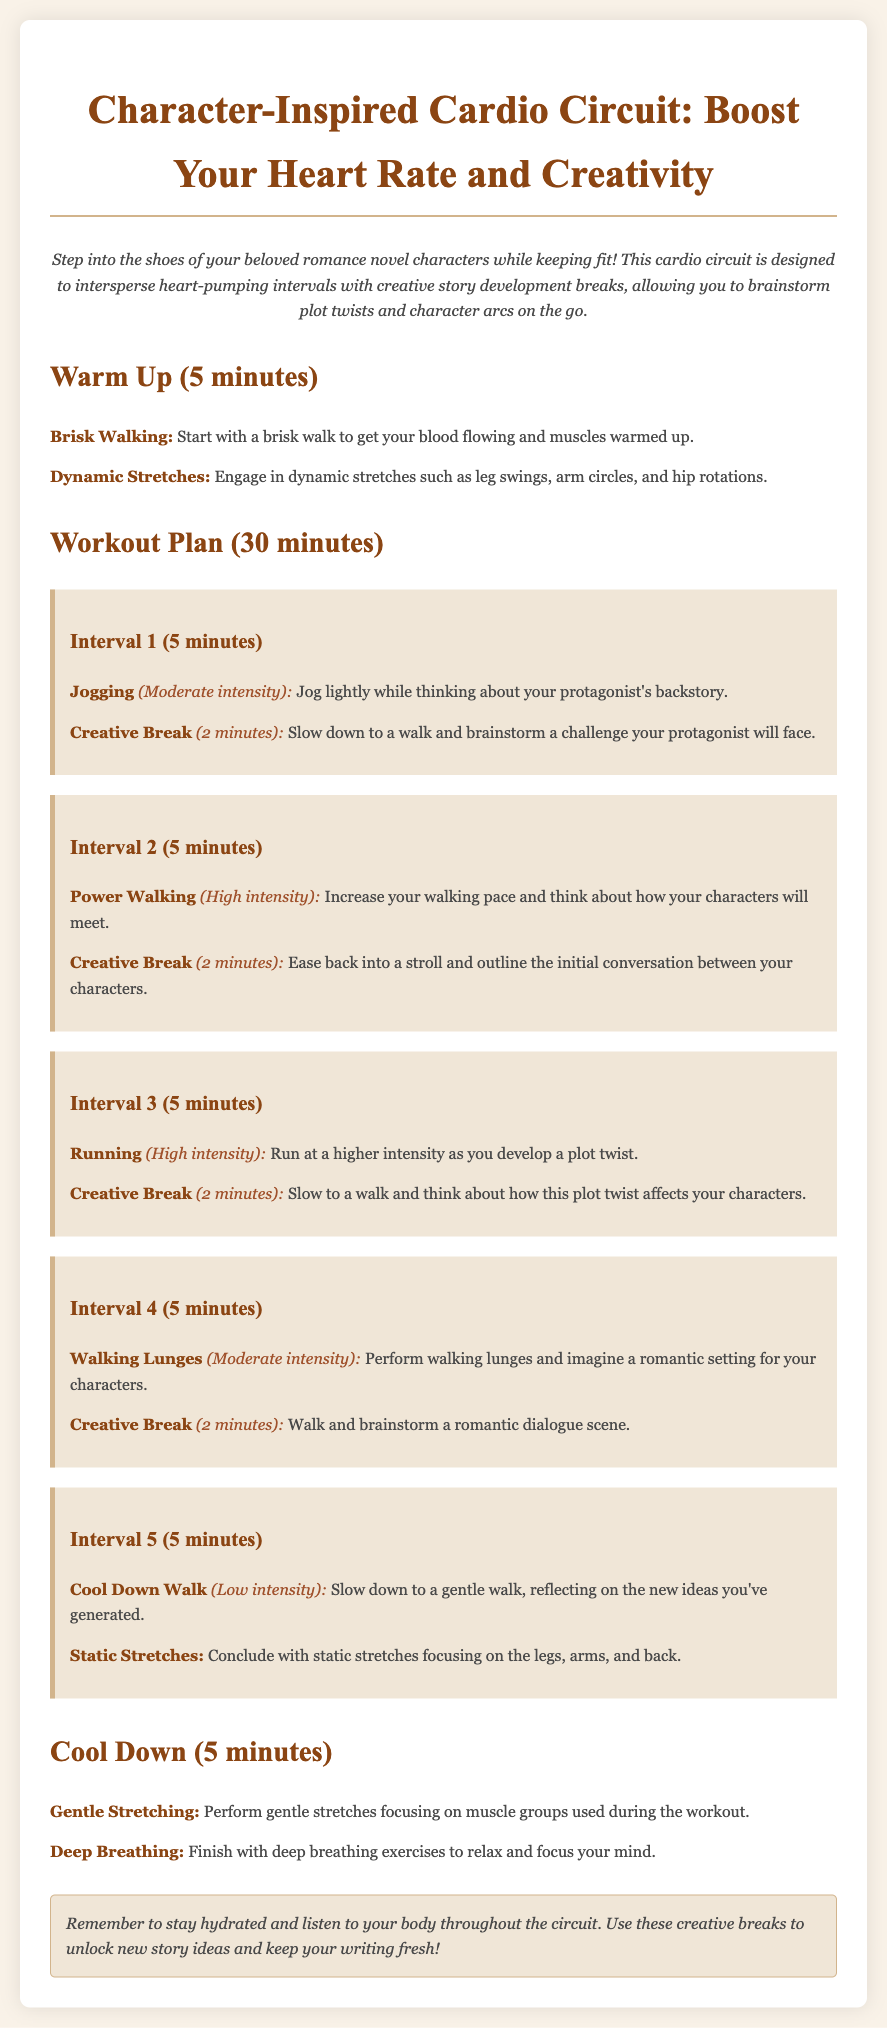What is the duration of the warm-up? The warm-up duration is specified in the workout plan as 5 minutes.
Answer: 5 minutes What intensity level is associated with jogging? The intensity level for jogging is described as moderate intensity in the document.
Answer: Moderate intensity What should you think about during the power walking phase? During the power walking phase, you are instructed to think about how your characters will meet.
Answer: How your characters will meet How many total intervals are in the workout plan? The workout plan consists of five distinct intervals specified in the document.
Answer: Five What type of stretches are recommended for cool down? The cool down section mentions gentle stretching as a recommended activity.
Answer: Gentle Stretching What is the last activity in the workout plan? The last activity listed in the workout plan is deep breathing exercises.
Answer: Deep Breathing What is the purpose of the creative breaks in the circuit? The creative breaks are designed to allow brainstorming of plot twists and character arcs.
Answer: Brainstorming plot twists What is advised to do during static stretches? During static stretches, the guidance is to focus on the legs, arms, and back.
Answer: Legs, arms, and back 